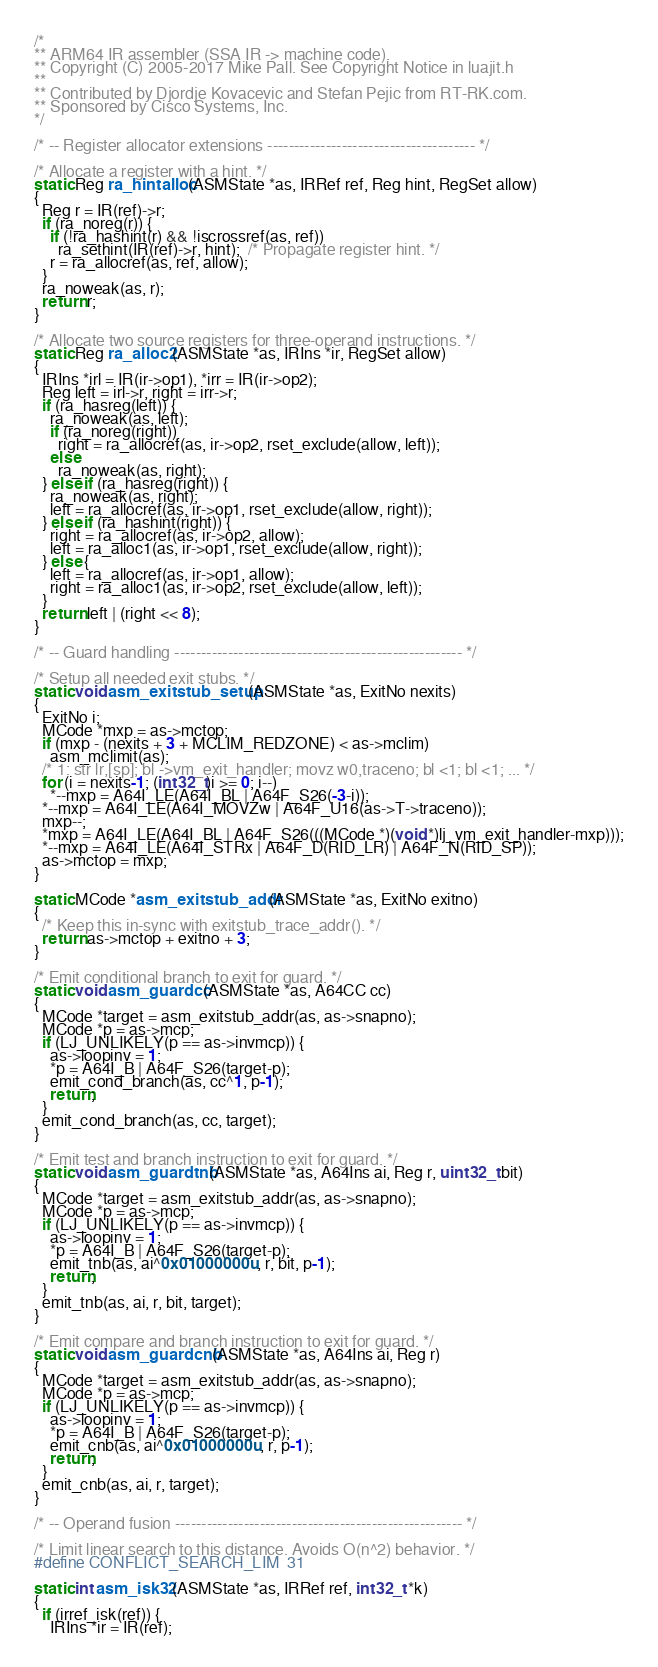<code> <loc_0><loc_0><loc_500><loc_500><_C_>/*
** ARM64 IR assembler (SSA IR -> machine code).
** Copyright (C) 2005-2017 Mike Pall. See Copyright Notice in luajit.h
**
** Contributed by Djordje Kovacevic and Stefan Pejic from RT-RK.com.
** Sponsored by Cisco Systems, Inc.
*/

/* -- Register allocator extensions --------------------------------------- */

/* Allocate a register with a hint. */
static Reg ra_hintalloc(ASMState *as, IRRef ref, Reg hint, RegSet allow)
{
  Reg r = IR(ref)->r;
  if (ra_noreg(r)) {
    if (!ra_hashint(r) && !iscrossref(as, ref))
      ra_sethint(IR(ref)->r, hint);  /* Propagate register hint. */
    r = ra_allocref(as, ref, allow);
  }
  ra_noweak(as, r);
  return r;
}

/* Allocate two source registers for three-operand instructions. */
static Reg ra_alloc2(ASMState *as, IRIns *ir, RegSet allow)
{
  IRIns *irl = IR(ir->op1), *irr = IR(ir->op2);
  Reg left = irl->r, right = irr->r;
  if (ra_hasreg(left)) {
    ra_noweak(as, left);
    if (ra_noreg(right))
      right = ra_allocref(as, ir->op2, rset_exclude(allow, left));
    else
      ra_noweak(as, right);
  } else if (ra_hasreg(right)) {
    ra_noweak(as, right);
    left = ra_allocref(as, ir->op1, rset_exclude(allow, right));
  } else if (ra_hashint(right)) {
    right = ra_allocref(as, ir->op2, allow);
    left = ra_alloc1(as, ir->op1, rset_exclude(allow, right));
  } else {
    left = ra_allocref(as, ir->op1, allow);
    right = ra_alloc1(as, ir->op2, rset_exclude(allow, left));
  }
  return left | (right << 8);
}

/* -- Guard handling ------------------------------------------------------ */

/* Setup all needed exit stubs. */
static void asm_exitstub_setup(ASMState *as, ExitNo nexits)
{
  ExitNo i;
  MCode *mxp = as->mctop;
  if (mxp - (nexits + 3 + MCLIM_REDZONE) < as->mclim)
    asm_mclimit(as);
  /* 1: str lr,[sp]; bl ->vm_exit_handler; movz w0,traceno; bl <1; bl <1; ... */
  for (i = nexits-1; (int32_t)i >= 0; i--)
    *--mxp = A64I_LE(A64I_BL | A64F_S26(-3-i));
  *--mxp = A64I_LE(A64I_MOVZw | A64F_U16(as->T->traceno));
  mxp--;
  *mxp = A64I_LE(A64I_BL | A64F_S26(((MCode *)(void *)lj_vm_exit_handler-mxp)));
  *--mxp = A64I_LE(A64I_STRx | A64F_D(RID_LR) | A64F_N(RID_SP));
  as->mctop = mxp;
}

static MCode *asm_exitstub_addr(ASMState *as, ExitNo exitno)
{
  /* Keep this in-sync with exitstub_trace_addr(). */
  return as->mctop + exitno + 3;
}

/* Emit conditional branch to exit for guard. */
static void asm_guardcc(ASMState *as, A64CC cc)
{
  MCode *target = asm_exitstub_addr(as, as->snapno);
  MCode *p = as->mcp;
  if (LJ_UNLIKELY(p == as->invmcp)) {
    as->loopinv = 1;
    *p = A64I_B | A64F_S26(target-p);
    emit_cond_branch(as, cc^1, p-1);
    return;
  }
  emit_cond_branch(as, cc, target);
}

/* Emit test and branch instruction to exit for guard. */
static void asm_guardtnb(ASMState *as, A64Ins ai, Reg r, uint32_t bit)
{
  MCode *target = asm_exitstub_addr(as, as->snapno);
  MCode *p = as->mcp;
  if (LJ_UNLIKELY(p == as->invmcp)) {
    as->loopinv = 1;
    *p = A64I_B | A64F_S26(target-p);
    emit_tnb(as, ai^0x01000000u, r, bit, p-1);
    return;
  }
  emit_tnb(as, ai, r, bit, target);
}

/* Emit compare and branch instruction to exit for guard. */
static void asm_guardcnb(ASMState *as, A64Ins ai, Reg r)
{
  MCode *target = asm_exitstub_addr(as, as->snapno);
  MCode *p = as->mcp;
  if (LJ_UNLIKELY(p == as->invmcp)) {
    as->loopinv = 1;
    *p = A64I_B | A64F_S26(target-p);
    emit_cnb(as, ai^0x01000000u, r, p-1);
    return;
  }
  emit_cnb(as, ai, r, target);
}

/* -- Operand fusion ------------------------------------------------------ */

/* Limit linear search to this distance. Avoids O(n^2) behavior. */
#define CONFLICT_SEARCH_LIM	31

static int asm_isk32(ASMState *as, IRRef ref, int32_t *k)
{
  if (irref_isk(ref)) {
    IRIns *ir = IR(ref);</code> 